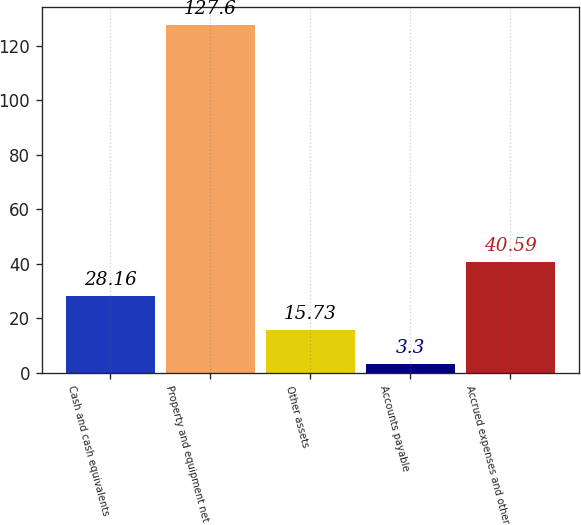Convert chart to OTSL. <chart><loc_0><loc_0><loc_500><loc_500><bar_chart><fcel>Cash and cash equivalents<fcel>Property and equipment net<fcel>Other assets<fcel>Accounts payable<fcel>Accrued expenses and other<nl><fcel>28.16<fcel>127.6<fcel>15.73<fcel>3.3<fcel>40.59<nl></chart> 